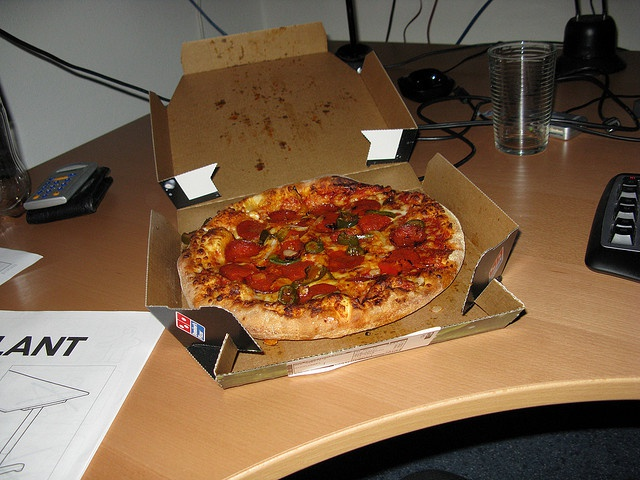Describe the objects in this image and their specific colors. I can see pizza in purple, maroon, brown, and tan tones, cup in purple, black, and gray tones, keyboard in purple, black, gray, and darkgray tones, remote in purple, black, gray, and navy tones, and vase in purple, black, and gray tones in this image. 